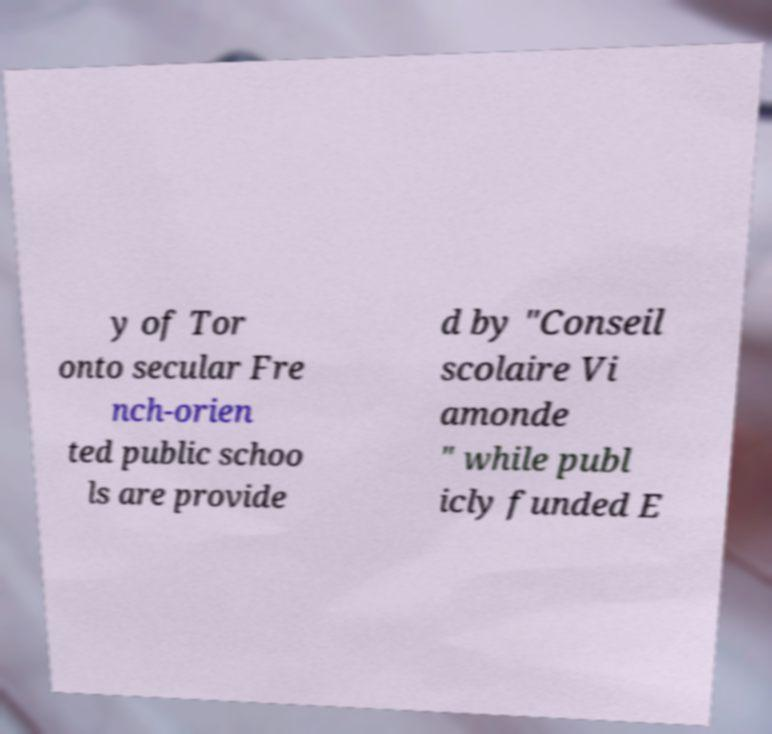Could you assist in decoding the text presented in this image and type it out clearly? y of Tor onto secular Fre nch-orien ted public schoo ls are provide d by "Conseil scolaire Vi amonde " while publ icly funded E 